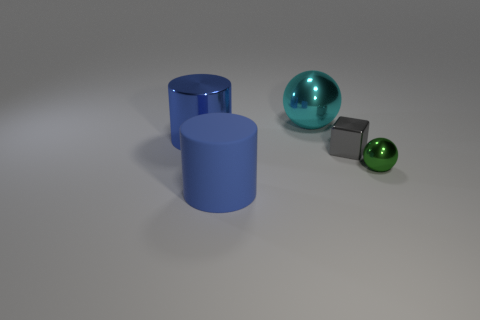Add 5 tiny green objects. How many objects exist? 10 Subtract all cylinders. How many objects are left? 3 Add 4 gray metal objects. How many gray metal objects are left? 5 Add 3 cylinders. How many cylinders exist? 5 Subtract 0 brown spheres. How many objects are left? 5 Subtract all tiny metallic spheres. Subtract all large blue rubber cylinders. How many objects are left? 3 